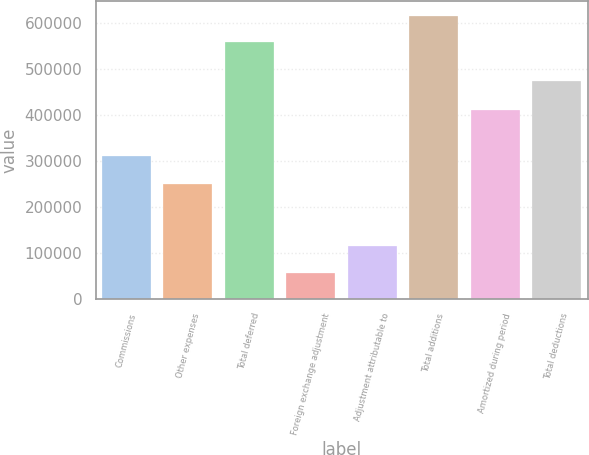<chart> <loc_0><loc_0><loc_500><loc_500><bar_chart><fcel>Commissions<fcel>Other expenses<fcel>Total deferred<fcel>Foreign exchange adjustment<fcel>Adjustment attributable to<fcel>Total additions<fcel>Amortized during period<fcel>Total deductions<nl><fcel>309722<fcel>248984<fcel>558706<fcel>56934.3<fcel>113866<fcel>615638<fcel>410485<fcel>473250<nl></chart> 